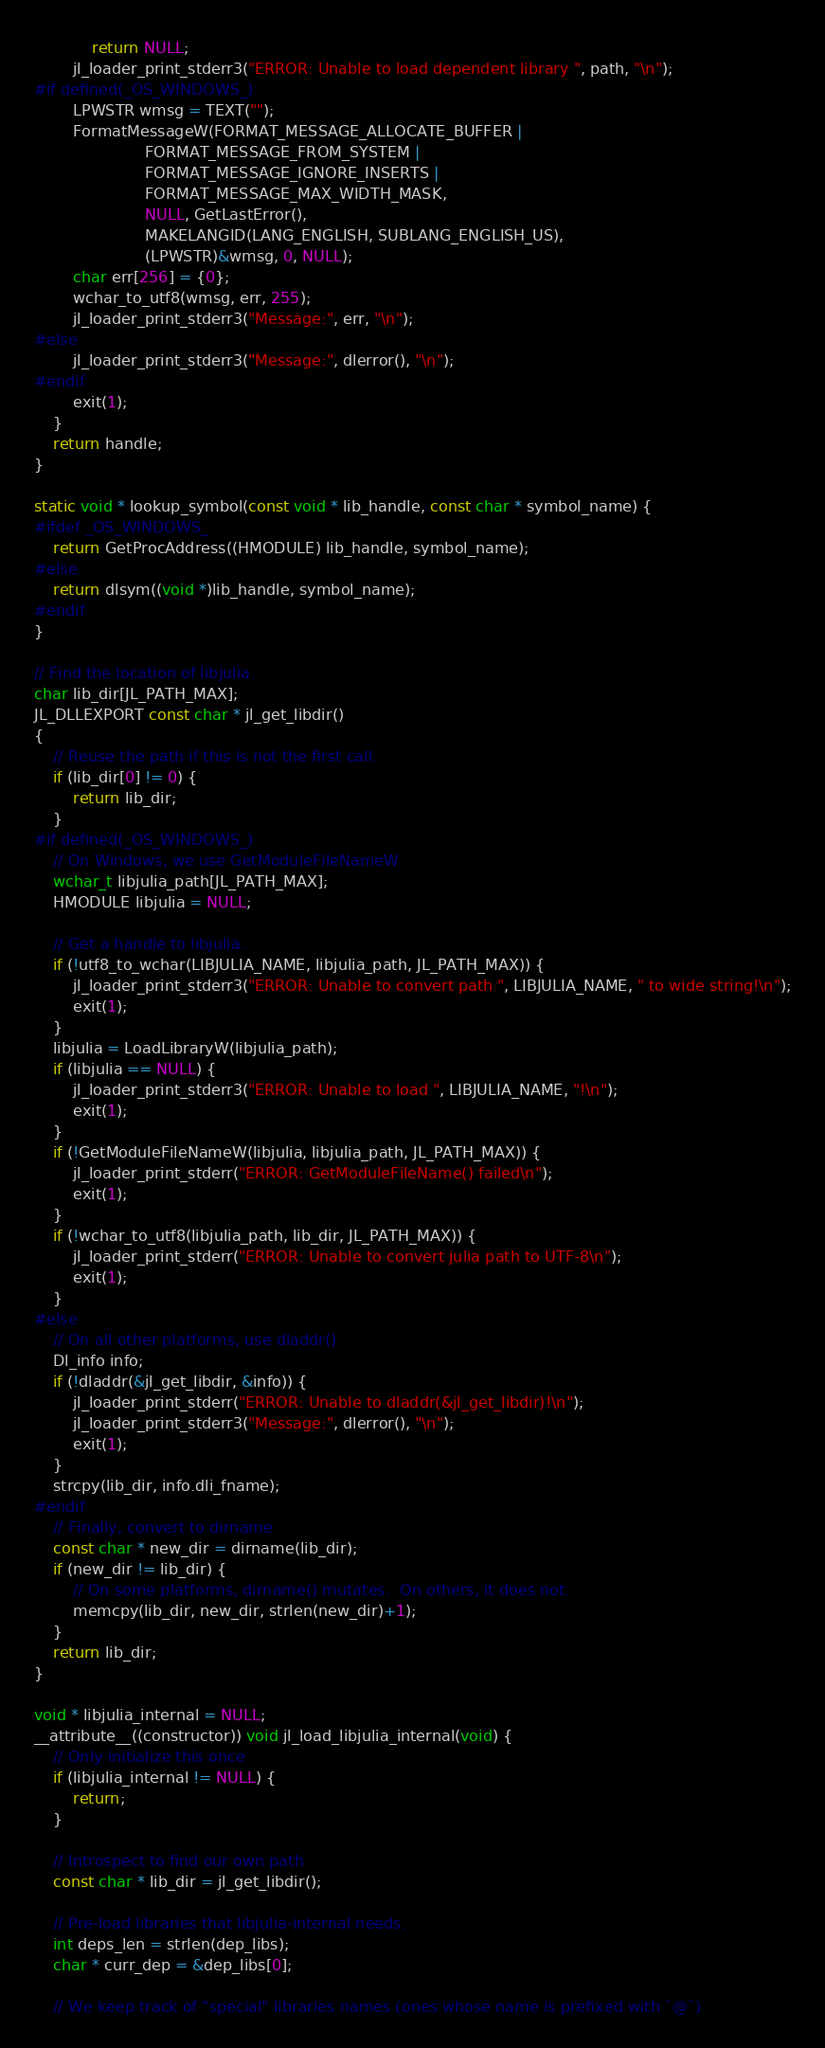Convert code to text. <code><loc_0><loc_0><loc_500><loc_500><_C_>            return NULL;
        jl_loader_print_stderr3("ERROR: Unable to load dependent library ", path, "\n");
#if defined(_OS_WINDOWS_)
        LPWSTR wmsg = TEXT("");
        FormatMessageW(FORMAT_MESSAGE_ALLOCATE_BUFFER |
                       FORMAT_MESSAGE_FROM_SYSTEM |
                       FORMAT_MESSAGE_IGNORE_INSERTS |
                       FORMAT_MESSAGE_MAX_WIDTH_MASK,
                       NULL, GetLastError(),
                       MAKELANGID(LANG_ENGLISH, SUBLANG_ENGLISH_US),
                       (LPWSTR)&wmsg, 0, NULL);
        char err[256] = {0};
        wchar_to_utf8(wmsg, err, 255);
        jl_loader_print_stderr3("Message:", err, "\n");
#else
        jl_loader_print_stderr3("Message:", dlerror(), "\n");
#endif
        exit(1);
    }
    return handle;
}

static void * lookup_symbol(const void * lib_handle, const char * symbol_name) {
#ifdef _OS_WINDOWS_
    return GetProcAddress((HMODULE) lib_handle, symbol_name);
#else
    return dlsym((void *)lib_handle, symbol_name);
#endif
}

// Find the location of libjulia.
char lib_dir[JL_PATH_MAX];
JL_DLLEXPORT const char * jl_get_libdir()
{
    // Reuse the path if this is not the first call.
    if (lib_dir[0] != 0) {
        return lib_dir;
    }
#if defined(_OS_WINDOWS_)
    // On Windows, we use GetModuleFileNameW
    wchar_t libjulia_path[JL_PATH_MAX];
    HMODULE libjulia = NULL;

    // Get a handle to libjulia.
    if (!utf8_to_wchar(LIBJULIA_NAME, libjulia_path, JL_PATH_MAX)) {
        jl_loader_print_stderr3("ERROR: Unable to convert path ", LIBJULIA_NAME, " to wide string!\n");
        exit(1);
    }
    libjulia = LoadLibraryW(libjulia_path);
    if (libjulia == NULL) {
        jl_loader_print_stderr3("ERROR: Unable to load ", LIBJULIA_NAME, "!\n");
        exit(1);
    }
    if (!GetModuleFileNameW(libjulia, libjulia_path, JL_PATH_MAX)) {
        jl_loader_print_stderr("ERROR: GetModuleFileName() failed\n");
        exit(1);
    }
    if (!wchar_to_utf8(libjulia_path, lib_dir, JL_PATH_MAX)) {
        jl_loader_print_stderr("ERROR: Unable to convert julia path to UTF-8\n");
        exit(1);
    }
#else
    // On all other platforms, use dladdr()
    Dl_info info;
    if (!dladdr(&jl_get_libdir, &info)) {
        jl_loader_print_stderr("ERROR: Unable to dladdr(&jl_get_libdir)!\n");
        jl_loader_print_stderr3("Message:", dlerror(), "\n");
        exit(1);
    }
    strcpy(lib_dir, info.dli_fname);
#endif
    // Finally, convert to dirname
    const char * new_dir = dirname(lib_dir);
    if (new_dir != lib_dir) {
        // On some platforms, dirname() mutates.  On others, it does not.
        memcpy(lib_dir, new_dir, strlen(new_dir)+1);
    }
    return lib_dir;
}

void * libjulia_internal = NULL;
__attribute__((constructor)) void jl_load_libjulia_internal(void) {
    // Only initialize this once
    if (libjulia_internal != NULL) {
        return;
    }

    // Introspect to find our own path
    const char * lib_dir = jl_get_libdir();

    // Pre-load libraries that libjulia-internal needs.
    int deps_len = strlen(dep_libs);
    char * curr_dep = &dep_libs[0];

    // We keep track of "special" libraries names (ones whose name is prefixed with `@`)</code> 